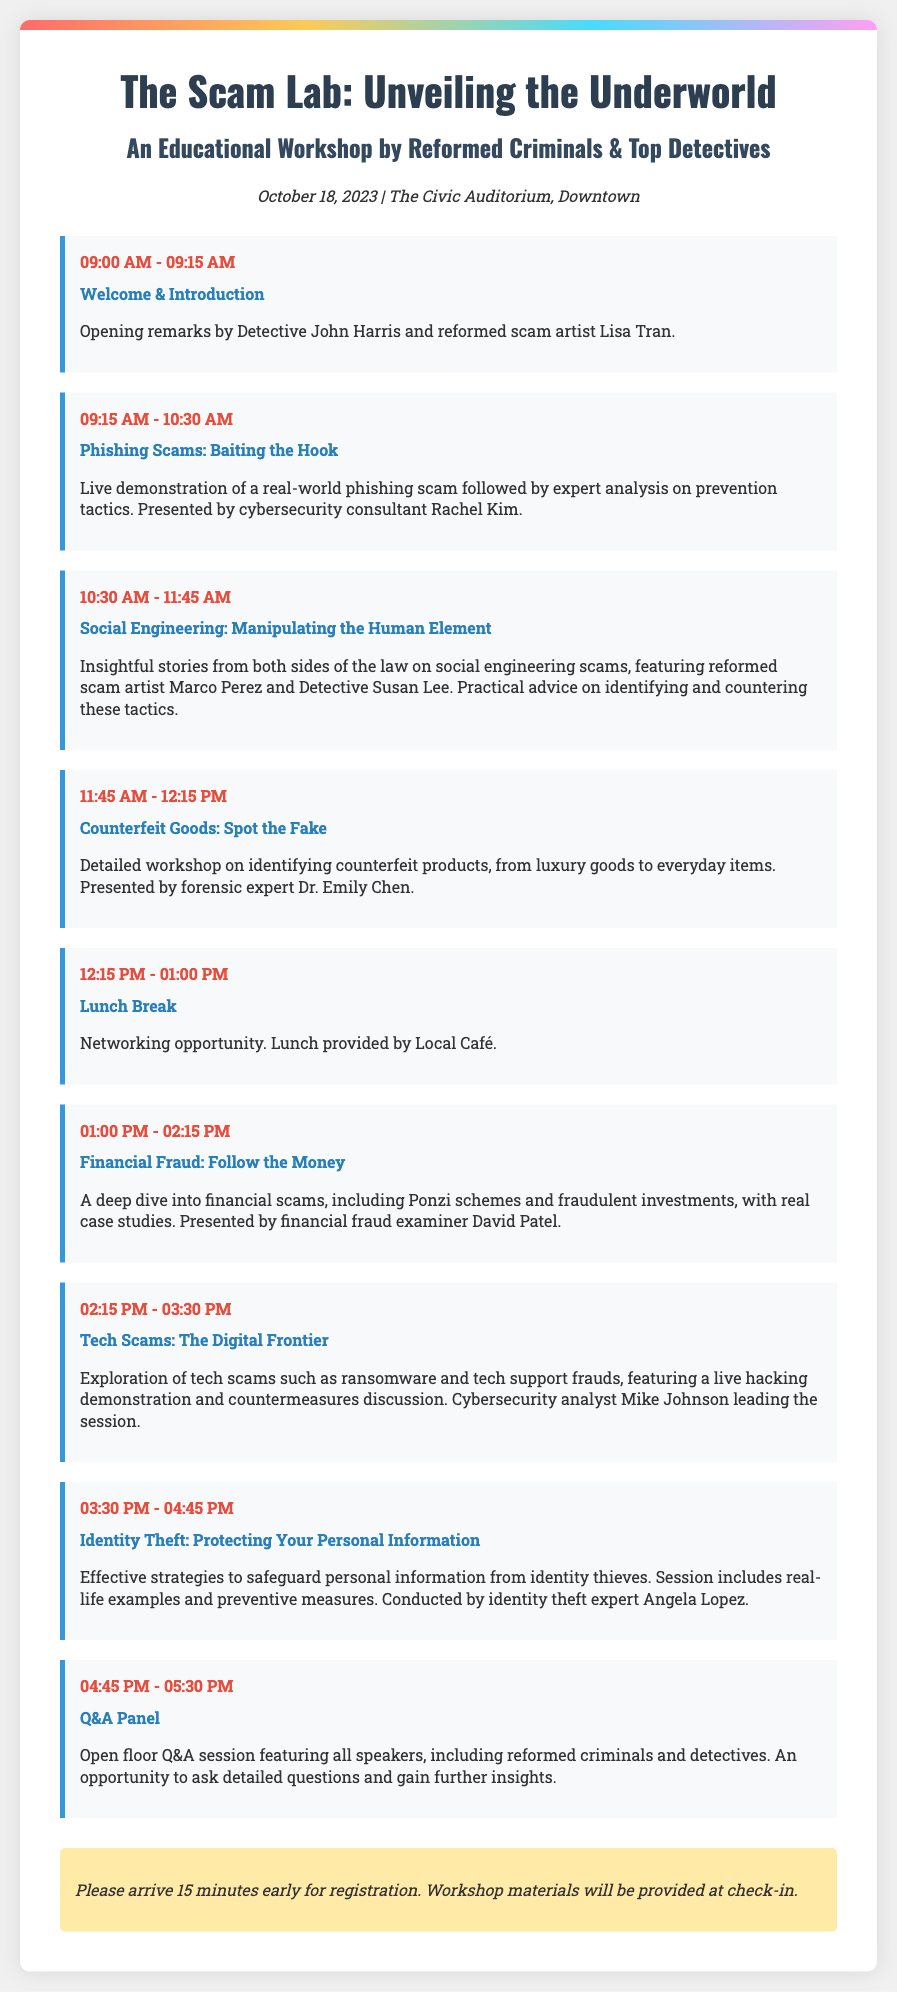What date is the workshop scheduled for? The workshop is scheduled for October 18, 2023, as mentioned in the event details section.
Answer: October 18, 2023 Who presents the session on Phishing Scams? The session on Phishing Scams is presented by cybersecurity consultant Rachel Kim.
Answer: Rachel Kim What time does the Q&A Panel begin? The Q&A Panel is scheduled to begin at 4:45 PM, according to the schedule section.
Answer: 4:45 PM How long is the Lunch Break scheduled for? The Lunch Break is scheduled for 45 minutes, as indicated in the time allocation for that session.
Answer: 45 minutes What is the focus of the session titled "Identity Theft"? The session on Identity Theft focuses on effective strategies to safeguard personal information.
Answer: Safeguard personal information What is required for participation according to the special note? Attendees are advised to arrive 15 minutes early for registration, as stated in the special note section.
Answer: 15 minutes early Which session includes a live demonstration? The session titled "Tech Scams: The Digital Frontier" includes a live hacking demonstration.
Answer: Tech Scams: The Digital Frontier Who are the opening speakers for the workshop? Opening remarks are made by Detective John Harris and reformed scam artist Lisa Tran.
Answer: Detective John Harris and Lisa Tran 